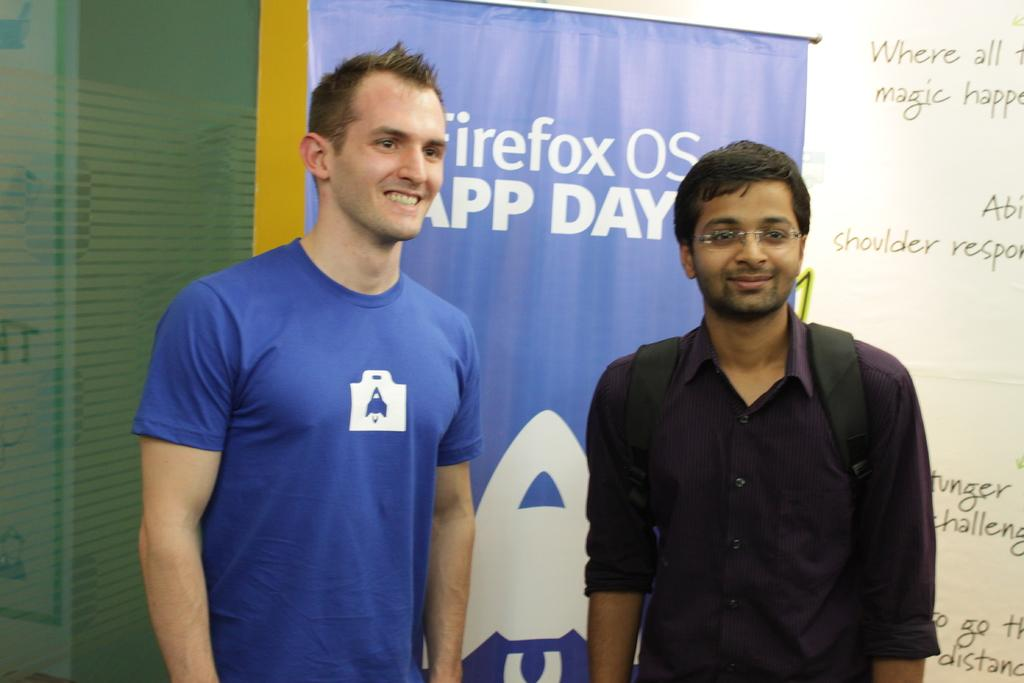<image>
Write a terse but informative summary of the picture. Two men are posing in front of a sign for Firefox OS 